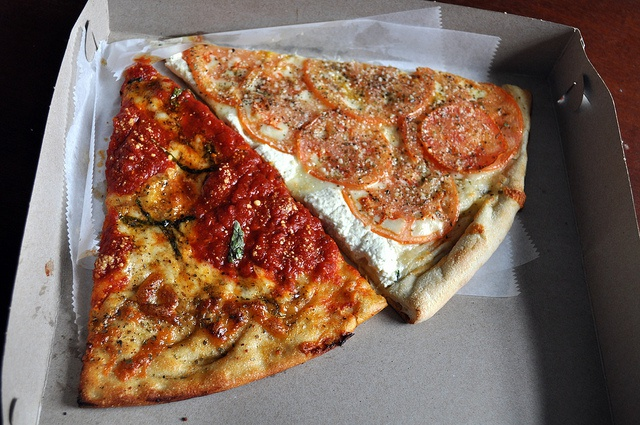Describe the objects in this image and their specific colors. I can see pizza in black, maroon, brown, and tan tones and pizza in black, brown, ivory, gray, and tan tones in this image. 